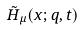Convert formula to latex. <formula><loc_0><loc_0><loc_500><loc_500>\tilde { H } _ { \mu } ( x ; q , t )</formula> 